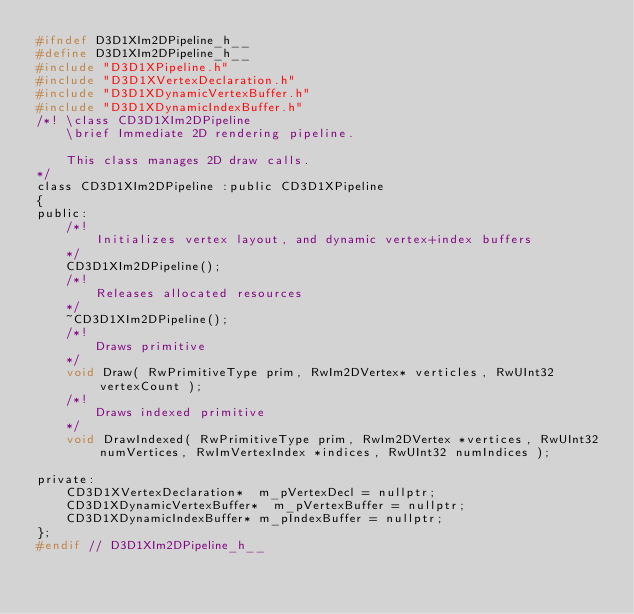Convert code to text. <code><loc_0><loc_0><loc_500><loc_500><_C_>#ifndef D3D1XIm2DPipeline_h__
#define D3D1XIm2DPipeline_h__
#include "D3D1XPipeline.h"
#include "D3D1XVertexDeclaration.h"
#include "D3D1XDynamicVertexBuffer.h"
#include "D3D1XDynamicIndexBuffer.h"
/*! \class CD3D1XIm2DPipeline
    \brief Immediate 2D rendering pipeline.

    This class manages 2D draw calls.
*/
class CD3D1XIm2DPipeline :public CD3D1XPipeline
{
public:
    /*!
        Initializes vertex layout, and dynamic vertex+index buffers
    */
    CD3D1XIm2DPipeline();
    /*!
        Releases allocated resources
    */
    ~CD3D1XIm2DPipeline();
    /*!
        Draws primitive
    */
    void Draw( RwPrimitiveType prim, RwIm2DVertex* verticles, RwUInt32 vertexCount );
    /*!
        Draws indexed primitive
    */
    void DrawIndexed( RwPrimitiveType prim, RwIm2DVertex *vertices, RwUInt32 numVertices, RwImVertexIndex *indices, RwUInt32 numIndices );

private:
    CD3D1XVertexDeclaration*	m_pVertexDecl = nullptr;
    CD3D1XDynamicVertexBuffer*	m_pVertexBuffer = nullptr;
    CD3D1XDynamicIndexBuffer*	m_pIndexBuffer = nullptr;
};
#endif // D3D1XIm2DPipeline_h__

</code> 